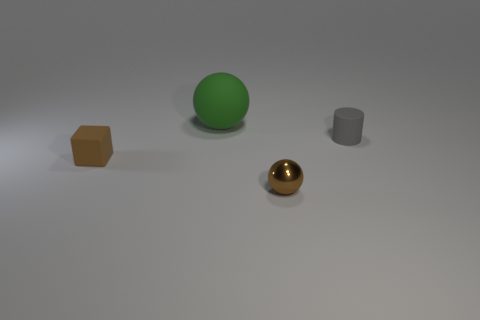Subtract all cylinders. How many objects are left? 3 Add 4 small purple blocks. How many objects exist? 8 Subtract all large red matte objects. Subtract all matte objects. How many objects are left? 1 Add 1 small metallic things. How many small metallic things are left? 2 Add 3 metal spheres. How many metal spheres exist? 4 Subtract 1 brown blocks. How many objects are left? 3 